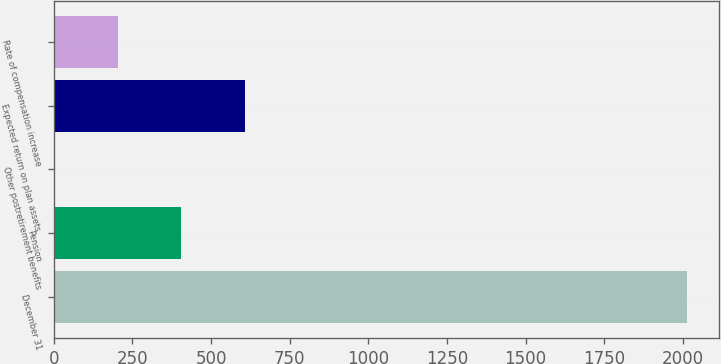<chart> <loc_0><loc_0><loc_500><loc_500><bar_chart><fcel>December 31<fcel>Pension<fcel>Other postretirement benefits<fcel>Expected return on plan assets<fcel>Rate of compensation increase<nl><fcel>2014<fcel>405.6<fcel>3.5<fcel>606.65<fcel>204.55<nl></chart> 